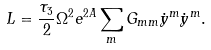Convert formula to latex. <formula><loc_0><loc_0><loc_500><loc_500>L = \frac { \tau _ { 3 } } { 2 } \Omega ^ { 2 } e ^ { 2 A } \sum _ { m } G _ { m m } \dot { y } ^ { m } \dot { y } ^ { m } .</formula> 